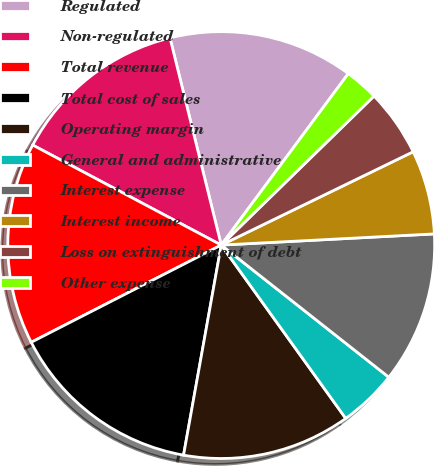Convert chart. <chart><loc_0><loc_0><loc_500><loc_500><pie_chart><fcel>Regulated<fcel>Non-regulated<fcel>Total revenue<fcel>Total cost of sales<fcel>Operating margin<fcel>General and administrative<fcel>Interest expense<fcel>Interest income<fcel>Loss on extinguishment of debt<fcel>Other expense<nl><fcel>14.01%<fcel>13.38%<fcel>15.29%<fcel>14.65%<fcel>12.74%<fcel>4.46%<fcel>11.46%<fcel>6.37%<fcel>5.1%<fcel>2.55%<nl></chart> 